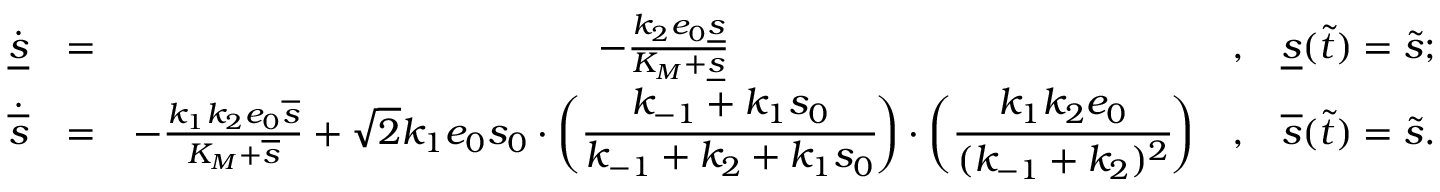Convert formula to latex. <formula><loc_0><loc_0><loc_500><loc_500>\begin{array} { r c c c l } { \dot { \underline { s } } } & { = } & { - \frac { k _ { 2 } e _ { 0 } \underline { s } } { K _ { M } + \underline { s } } } & { , } & { \underline { s } ( \widetilde { t } ) = \widetilde { s } ; } \\ { \dot { \overline { s } } } & { = } & { - \frac { k _ { 1 } k _ { 2 } e _ { 0 } \overline { s } } { K _ { M } + \overline { s } } + \sqrt { 2 } k _ { 1 } e _ { 0 } s _ { 0 } \cdot \left ( \cfrac { k _ { - 1 } + k _ { 1 } s _ { 0 } } { k _ { - 1 } + k _ { 2 } + k _ { 1 } s _ { 0 } } \right ) \cdot \left ( \cfrac { k _ { 1 } k _ { 2 } e _ { 0 } } { ( k _ { - 1 } + k _ { 2 } ) ^ { 2 } } \right ) } & { , } & { \overline { s } ( \widetilde { t } ) = \widetilde { s } . } \end{array}</formula> 